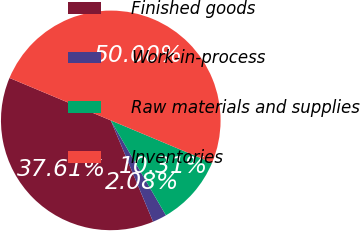Convert chart to OTSL. <chart><loc_0><loc_0><loc_500><loc_500><pie_chart><fcel>Finished goods<fcel>Work-in-process<fcel>Raw materials and supplies<fcel>Inventories<nl><fcel>37.61%<fcel>2.08%<fcel>10.31%<fcel>50.0%<nl></chart> 